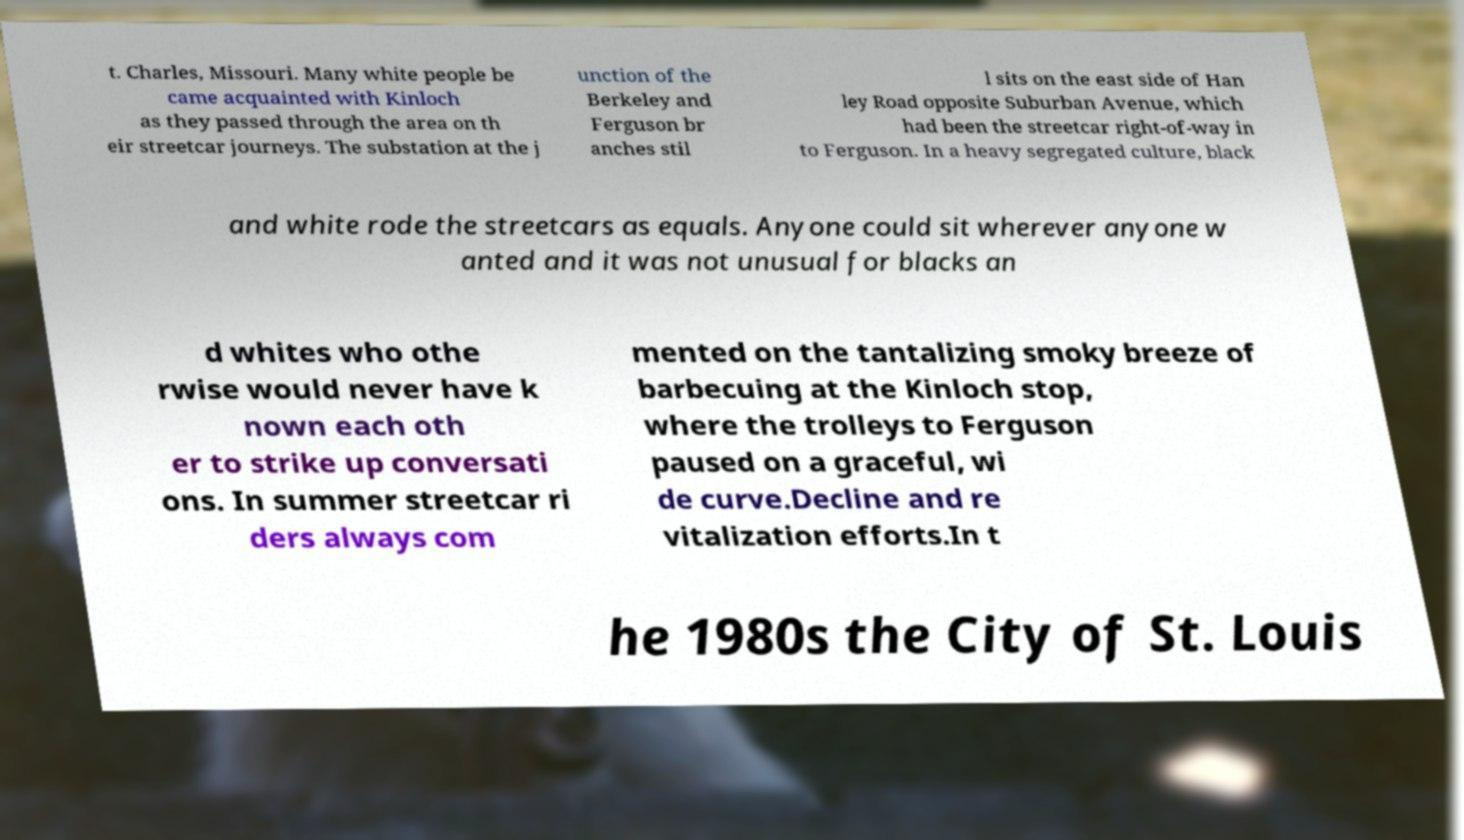There's text embedded in this image that I need extracted. Can you transcribe it verbatim? t. Charles, Missouri. Many white people be came acquainted with Kinloch as they passed through the area on th eir streetcar journeys. The substation at the j unction of the Berkeley and Ferguson br anches stil l sits on the east side of Han ley Road opposite Suburban Avenue, which had been the streetcar right-of-way in to Ferguson. In a heavy segregated culture, black and white rode the streetcars as equals. Anyone could sit wherever anyone w anted and it was not unusual for blacks an d whites who othe rwise would never have k nown each oth er to strike up conversati ons. In summer streetcar ri ders always com mented on the tantalizing smoky breeze of barbecuing at the Kinloch stop, where the trolleys to Ferguson paused on a graceful, wi de curve.Decline and re vitalization efforts.In t he 1980s the City of St. Louis 